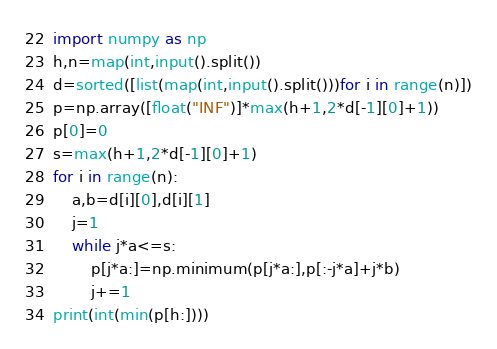Convert code to text. <code><loc_0><loc_0><loc_500><loc_500><_Python_>import numpy as np
h,n=map(int,input().split())
d=sorted([list(map(int,input().split()))for i in range(n)])
p=np.array([float("INF")]*max(h+1,2*d[-1][0]+1))
p[0]=0
s=max(h+1,2*d[-1][0]+1)
for i in range(n):
    a,b=d[i][0],d[i][1]
    j=1
    while j*a<=s:
        p[j*a:]=np.minimum(p[j*a:],p[:-j*a]+j*b)
        j+=1
print(int(min(p[h:])))</code> 